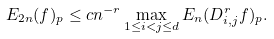Convert formula to latex. <formula><loc_0><loc_0><loc_500><loc_500>E _ { 2 n } ( f ) _ { p } \leq c n ^ { - r } \max _ { 1 \leq i < j \leq d } E _ { n } ( D _ { i , j } ^ { r } f ) _ { p } .</formula> 